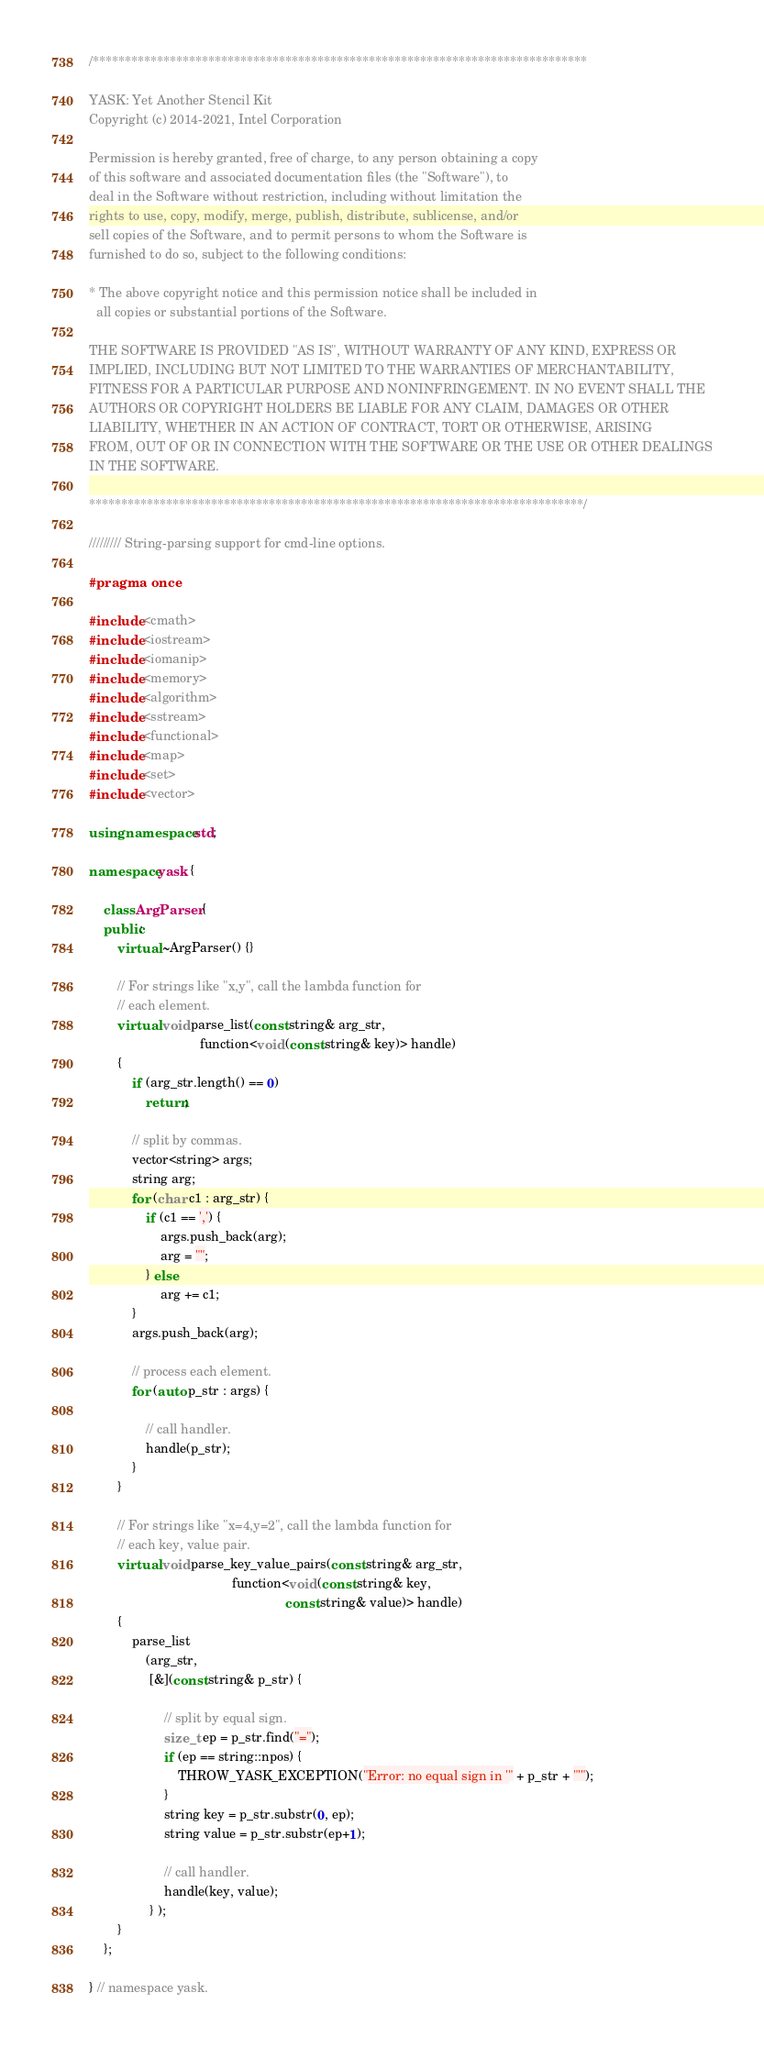<code> <loc_0><loc_0><loc_500><loc_500><_C++_>/*****************************************************************************

YASK: Yet Another Stencil Kit
Copyright (c) 2014-2021, Intel Corporation

Permission is hereby granted, free of charge, to any person obtaining a copy
of this software and associated documentation files (the "Software"), to
deal in the Software without restriction, including without limitation the
rights to use, copy, modify, merge, publish, distribute, sublicense, and/or
sell copies of the Software, and to permit persons to whom the Software is
furnished to do so, subject to the following conditions:

* The above copyright notice and this permission notice shall be included in
  all copies or substantial portions of the Software.

THE SOFTWARE IS PROVIDED "AS IS", WITHOUT WARRANTY OF ANY KIND, EXPRESS OR
IMPLIED, INCLUDING BUT NOT LIMITED TO THE WARRANTIES OF MERCHANTABILITY,
FITNESS FOR A PARTICULAR PURPOSE AND NONINFRINGEMENT. IN NO EVENT SHALL THE
AUTHORS OR COPYRIGHT HOLDERS BE LIABLE FOR ANY CLAIM, DAMAGES OR OTHER
LIABILITY, WHETHER IN AN ACTION OF CONTRACT, TORT OR OTHERWISE, ARISING
FROM, OUT OF OR IN CONNECTION WITH THE SOFTWARE OR THE USE OR OTHER DEALINGS
IN THE SOFTWARE.

*****************************************************************************/

///////// String-parsing support for cmd-line options.

#pragma once

#include <cmath>
#include <iostream>
#include <iomanip>
#include <memory>
#include <algorithm>
#include <sstream>
#include <functional>
#include <map>
#include <set>
#include <vector>

using namespace std;

namespace yask {

    class ArgParser {
    public:
    	virtual ~ArgParser() {}

        // For strings like "x,y", call the lambda function for
        // each element.
        virtual void parse_list(const string& arg_str,
                               function<void (const string& key)> handle)
        {
            if (arg_str.length() == 0)
                return;

            // split by commas.
            vector<string> args;
            string arg;
            for (char c1 : arg_str) {
                if (c1 == ',') {
                    args.push_back(arg);
                    arg = "";
                } else
                    arg += c1;
            }
            args.push_back(arg);

            // process each element.
            for (auto p_str : args) {

                // call handler.
                handle(p_str);
            }
        }

        // For strings like "x=4,y=2", call the lambda function for
        // each key, value pair.
        virtual void parse_key_value_pairs(const string& arg_str,
                                        function<void (const string& key,
                                                       const string& value)> handle)
        {
            parse_list
                (arg_str,
                 [&](const string& p_str) { 
            
                     // split by equal sign.
                     size_t ep = p_str.find("=");
                     if (ep == string::npos) {
                         THROW_YASK_EXCEPTION("Error: no equal sign in '" + p_str + "'");
                     }
                     string key = p_str.substr(0, ep);
                     string value = p_str.substr(ep+1);

                     // call handler.
                     handle(key, value);
                 } );
        }
    };

} // namespace yask.

</code> 